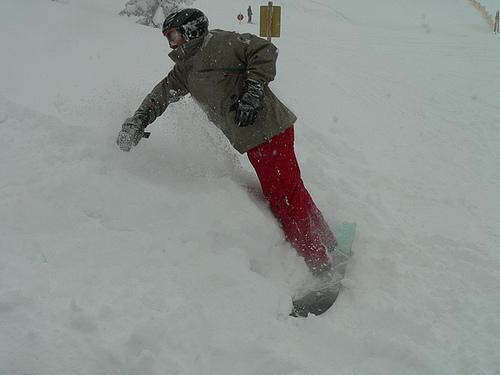Why is the person wearing a heavy jacket? Please explain your reasoning. cold weather. The person is snowboarding in a snow-covered area. 